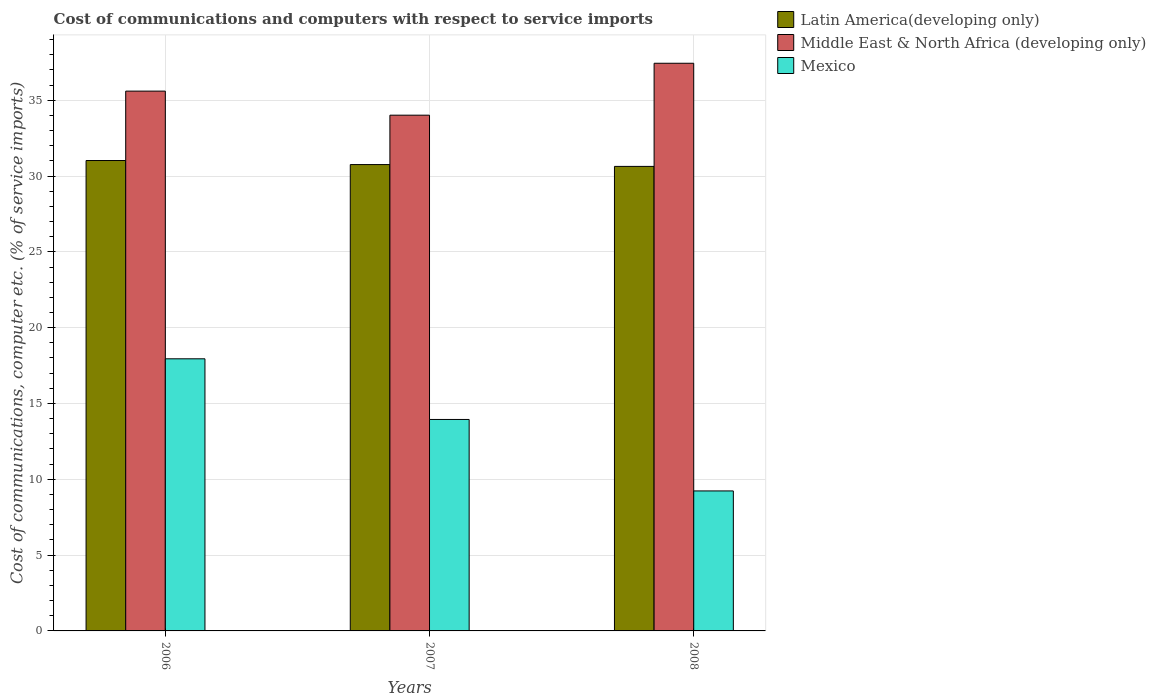How many different coloured bars are there?
Keep it short and to the point. 3. Are the number of bars per tick equal to the number of legend labels?
Provide a short and direct response. Yes. Are the number of bars on each tick of the X-axis equal?
Provide a short and direct response. Yes. What is the label of the 1st group of bars from the left?
Provide a short and direct response. 2006. In how many cases, is the number of bars for a given year not equal to the number of legend labels?
Your answer should be very brief. 0. What is the cost of communications and computers in Mexico in 2008?
Provide a succinct answer. 9.23. Across all years, what is the maximum cost of communications and computers in Middle East & North Africa (developing only)?
Ensure brevity in your answer.  37.44. Across all years, what is the minimum cost of communications and computers in Latin America(developing only)?
Ensure brevity in your answer.  30.64. In which year was the cost of communications and computers in Middle East & North Africa (developing only) minimum?
Provide a short and direct response. 2007. What is the total cost of communications and computers in Latin America(developing only) in the graph?
Give a very brief answer. 92.42. What is the difference between the cost of communications and computers in Mexico in 2007 and that in 2008?
Ensure brevity in your answer.  4.71. What is the difference between the cost of communications and computers in Middle East & North Africa (developing only) in 2007 and the cost of communications and computers in Latin America(developing only) in 2006?
Your response must be concise. 2.99. What is the average cost of communications and computers in Middle East & North Africa (developing only) per year?
Your answer should be compact. 35.68. In the year 2007, what is the difference between the cost of communications and computers in Latin America(developing only) and cost of communications and computers in Mexico?
Your answer should be very brief. 16.81. What is the ratio of the cost of communications and computers in Latin America(developing only) in 2006 to that in 2007?
Give a very brief answer. 1.01. Is the cost of communications and computers in Mexico in 2006 less than that in 2008?
Offer a very short reply. No. What is the difference between the highest and the second highest cost of communications and computers in Mexico?
Ensure brevity in your answer.  4. What is the difference between the highest and the lowest cost of communications and computers in Mexico?
Your response must be concise. 8.71. What does the 1st bar from the left in 2006 represents?
Your answer should be very brief. Latin America(developing only). What does the 3rd bar from the right in 2008 represents?
Make the answer very short. Latin America(developing only). What is the difference between two consecutive major ticks on the Y-axis?
Offer a very short reply. 5. Are the values on the major ticks of Y-axis written in scientific E-notation?
Give a very brief answer. No. What is the title of the graph?
Ensure brevity in your answer.  Cost of communications and computers with respect to service imports. What is the label or title of the Y-axis?
Offer a very short reply. Cost of communications, computer etc. (% of service imports). What is the Cost of communications, computer etc. (% of service imports) of Latin America(developing only) in 2006?
Your answer should be compact. 31.02. What is the Cost of communications, computer etc. (% of service imports) in Middle East & North Africa (developing only) in 2006?
Offer a very short reply. 35.6. What is the Cost of communications, computer etc. (% of service imports) in Mexico in 2006?
Keep it short and to the point. 17.95. What is the Cost of communications, computer etc. (% of service imports) of Latin America(developing only) in 2007?
Give a very brief answer. 30.76. What is the Cost of communications, computer etc. (% of service imports) of Middle East & North Africa (developing only) in 2007?
Offer a terse response. 34.01. What is the Cost of communications, computer etc. (% of service imports) of Mexico in 2007?
Give a very brief answer. 13.95. What is the Cost of communications, computer etc. (% of service imports) in Latin America(developing only) in 2008?
Keep it short and to the point. 30.64. What is the Cost of communications, computer etc. (% of service imports) in Middle East & North Africa (developing only) in 2008?
Offer a very short reply. 37.44. What is the Cost of communications, computer etc. (% of service imports) in Mexico in 2008?
Provide a short and direct response. 9.23. Across all years, what is the maximum Cost of communications, computer etc. (% of service imports) of Latin America(developing only)?
Provide a succinct answer. 31.02. Across all years, what is the maximum Cost of communications, computer etc. (% of service imports) in Middle East & North Africa (developing only)?
Give a very brief answer. 37.44. Across all years, what is the maximum Cost of communications, computer etc. (% of service imports) in Mexico?
Ensure brevity in your answer.  17.95. Across all years, what is the minimum Cost of communications, computer etc. (% of service imports) in Latin America(developing only)?
Offer a terse response. 30.64. Across all years, what is the minimum Cost of communications, computer etc. (% of service imports) of Middle East & North Africa (developing only)?
Offer a terse response. 34.01. Across all years, what is the minimum Cost of communications, computer etc. (% of service imports) of Mexico?
Make the answer very short. 9.23. What is the total Cost of communications, computer etc. (% of service imports) in Latin America(developing only) in the graph?
Make the answer very short. 92.42. What is the total Cost of communications, computer etc. (% of service imports) of Middle East & North Africa (developing only) in the graph?
Make the answer very short. 107.05. What is the total Cost of communications, computer etc. (% of service imports) of Mexico in the graph?
Provide a short and direct response. 41.13. What is the difference between the Cost of communications, computer etc. (% of service imports) of Latin America(developing only) in 2006 and that in 2007?
Give a very brief answer. 0.27. What is the difference between the Cost of communications, computer etc. (% of service imports) in Middle East & North Africa (developing only) in 2006 and that in 2007?
Offer a very short reply. 1.59. What is the difference between the Cost of communications, computer etc. (% of service imports) in Mexico in 2006 and that in 2007?
Provide a short and direct response. 4. What is the difference between the Cost of communications, computer etc. (% of service imports) in Latin America(developing only) in 2006 and that in 2008?
Give a very brief answer. 0.39. What is the difference between the Cost of communications, computer etc. (% of service imports) of Middle East & North Africa (developing only) in 2006 and that in 2008?
Ensure brevity in your answer.  -1.84. What is the difference between the Cost of communications, computer etc. (% of service imports) in Mexico in 2006 and that in 2008?
Make the answer very short. 8.71. What is the difference between the Cost of communications, computer etc. (% of service imports) in Latin America(developing only) in 2007 and that in 2008?
Your answer should be very brief. 0.12. What is the difference between the Cost of communications, computer etc. (% of service imports) of Middle East & North Africa (developing only) in 2007 and that in 2008?
Offer a terse response. -3.42. What is the difference between the Cost of communications, computer etc. (% of service imports) in Mexico in 2007 and that in 2008?
Provide a succinct answer. 4.71. What is the difference between the Cost of communications, computer etc. (% of service imports) in Latin America(developing only) in 2006 and the Cost of communications, computer etc. (% of service imports) in Middle East & North Africa (developing only) in 2007?
Your answer should be very brief. -2.99. What is the difference between the Cost of communications, computer etc. (% of service imports) of Latin America(developing only) in 2006 and the Cost of communications, computer etc. (% of service imports) of Mexico in 2007?
Offer a very short reply. 17.08. What is the difference between the Cost of communications, computer etc. (% of service imports) of Middle East & North Africa (developing only) in 2006 and the Cost of communications, computer etc. (% of service imports) of Mexico in 2007?
Keep it short and to the point. 21.65. What is the difference between the Cost of communications, computer etc. (% of service imports) in Latin America(developing only) in 2006 and the Cost of communications, computer etc. (% of service imports) in Middle East & North Africa (developing only) in 2008?
Your response must be concise. -6.42. What is the difference between the Cost of communications, computer etc. (% of service imports) in Latin America(developing only) in 2006 and the Cost of communications, computer etc. (% of service imports) in Mexico in 2008?
Ensure brevity in your answer.  21.79. What is the difference between the Cost of communications, computer etc. (% of service imports) in Middle East & North Africa (developing only) in 2006 and the Cost of communications, computer etc. (% of service imports) in Mexico in 2008?
Keep it short and to the point. 26.37. What is the difference between the Cost of communications, computer etc. (% of service imports) in Latin America(developing only) in 2007 and the Cost of communications, computer etc. (% of service imports) in Middle East & North Africa (developing only) in 2008?
Offer a very short reply. -6.68. What is the difference between the Cost of communications, computer etc. (% of service imports) in Latin America(developing only) in 2007 and the Cost of communications, computer etc. (% of service imports) in Mexico in 2008?
Provide a succinct answer. 21.52. What is the difference between the Cost of communications, computer etc. (% of service imports) of Middle East & North Africa (developing only) in 2007 and the Cost of communications, computer etc. (% of service imports) of Mexico in 2008?
Your answer should be compact. 24.78. What is the average Cost of communications, computer etc. (% of service imports) in Latin America(developing only) per year?
Provide a short and direct response. 30.81. What is the average Cost of communications, computer etc. (% of service imports) of Middle East & North Africa (developing only) per year?
Provide a succinct answer. 35.68. What is the average Cost of communications, computer etc. (% of service imports) in Mexico per year?
Ensure brevity in your answer.  13.71. In the year 2006, what is the difference between the Cost of communications, computer etc. (% of service imports) in Latin America(developing only) and Cost of communications, computer etc. (% of service imports) in Middle East & North Africa (developing only)?
Offer a terse response. -4.58. In the year 2006, what is the difference between the Cost of communications, computer etc. (% of service imports) of Latin America(developing only) and Cost of communications, computer etc. (% of service imports) of Mexico?
Provide a short and direct response. 13.08. In the year 2006, what is the difference between the Cost of communications, computer etc. (% of service imports) in Middle East & North Africa (developing only) and Cost of communications, computer etc. (% of service imports) in Mexico?
Offer a terse response. 17.65. In the year 2007, what is the difference between the Cost of communications, computer etc. (% of service imports) of Latin America(developing only) and Cost of communications, computer etc. (% of service imports) of Middle East & North Africa (developing only)?
Your response must be concise. -3.26. In the year 2007, what is the difference between the Cost of communications, computer etc. (% of service imports) in Latin America(developing only) and Cost of communications, computer etc. (% of service imports) in Mexico?
Your answer should be compact. 16.81. In the year 2007, what is the difference between the Cost of communications, computer etc. (% of service imports) of Middle East & North Africa (developing only) and Cost of communications, computer etc. (% of service imports) of Mexico?
Provide a short and direct response. 20.07. In the year 2008, what is the difference between the Cost of communications, computer etc. (% of service imports) in Latin America(developing only) and Cost of communications, computer etc. (% of service imports) in Middle East & North Africa (developing only)?
Give a very brief answer. -6.8. In the year 2008, what is the difference between the Cost of communications, computer etc. (% of service imports) of Latin America(developing only) and Cost of communications, computer etc. (% of service imports) of Mexico?
Your answer should be very brief. 21.4. In the year 2008, what is the difference between the Cost of communications, computer etc. (% of service imports) in Middle East & North Africa (developing only) and Cost of communications, computer etc. (% of service imports) in Mexico?
Your response must be concise. 28.21. What is the ratio of the Cost of communications, computer etc. (% of service imports) of Latin America(developing only) in 2006 to that in 2007?
Your response must be concise. 1.01. What is the ratio of the Cost of communications, computer etc. (% of service imports) in Middle East & North Africa (developing only) in 2006 to that in 2007?
Give a very brief answer. 1.05. What is the ratio of the Cost of communications, computer etc. (% of service imports) in Mexico in 2006 to that in 2007?
Keep it short and to the point. 1.29. What is the ratio of the Cost of communications, computer etc. (% of service imports) in Latin America(developing only) in 2006 to that in 2008?
Your answer should be compact. 1.01. What is the ratio of the Cost of communications, computer etc. (% of service imports) in Middle East & North Africa (developing only) in 2006 to that in 2008?
Your answer should be compact. 0.95. What is the ratio of the Cost of communications, computer etc. (% of service imports) of Mexico in 2006 to that in 2008?
Provide a succinct answer. 1.94. What is the ratio of the Cost of communications, computer etc. (% of service imports) of Middle East & North Africa (developing only) in 2007 to that in 2008?
Keep it short and to the point. 0.91. What is the ratio of the Cost of communications, computer etc. (% of service imports) of Mexico in 2007 to that in 2008?
Your answer should be very brief. 1.51. What is the difference between the highest and the second highest Cost of communications, computer etc. (% of service imports) in Latin America(developing only)?
Provide a short and direct response. 0.27. What is the difference between the highest and the second highest Cost of communications, computer etc. (% of service imports) in Middle East & North Africa (developing only)?
Ensure brevity in your answer.  1.84. What is the difference between the highest and the second highest Cost of communications, computer etc. (% of service imports) of Mexico?
Your answer should be very brief. 4. What is the difference between the highest and the lowest Cost of communications, computer etc. (% of service imports) of Latin America(developing only)?
Make the answer very short. 0.39. What is the difference between the highest and the lowest Cost of communications, computer etc. (% of service imports) of Middle East & North Africa (developing only)?
Provide a succinct answer. 3.42. What is the difference between the highest and the lowest Cost of communications, computer etc. (% of service imports) of Mexico?
Ensure brevity in your answer.  8.71. 